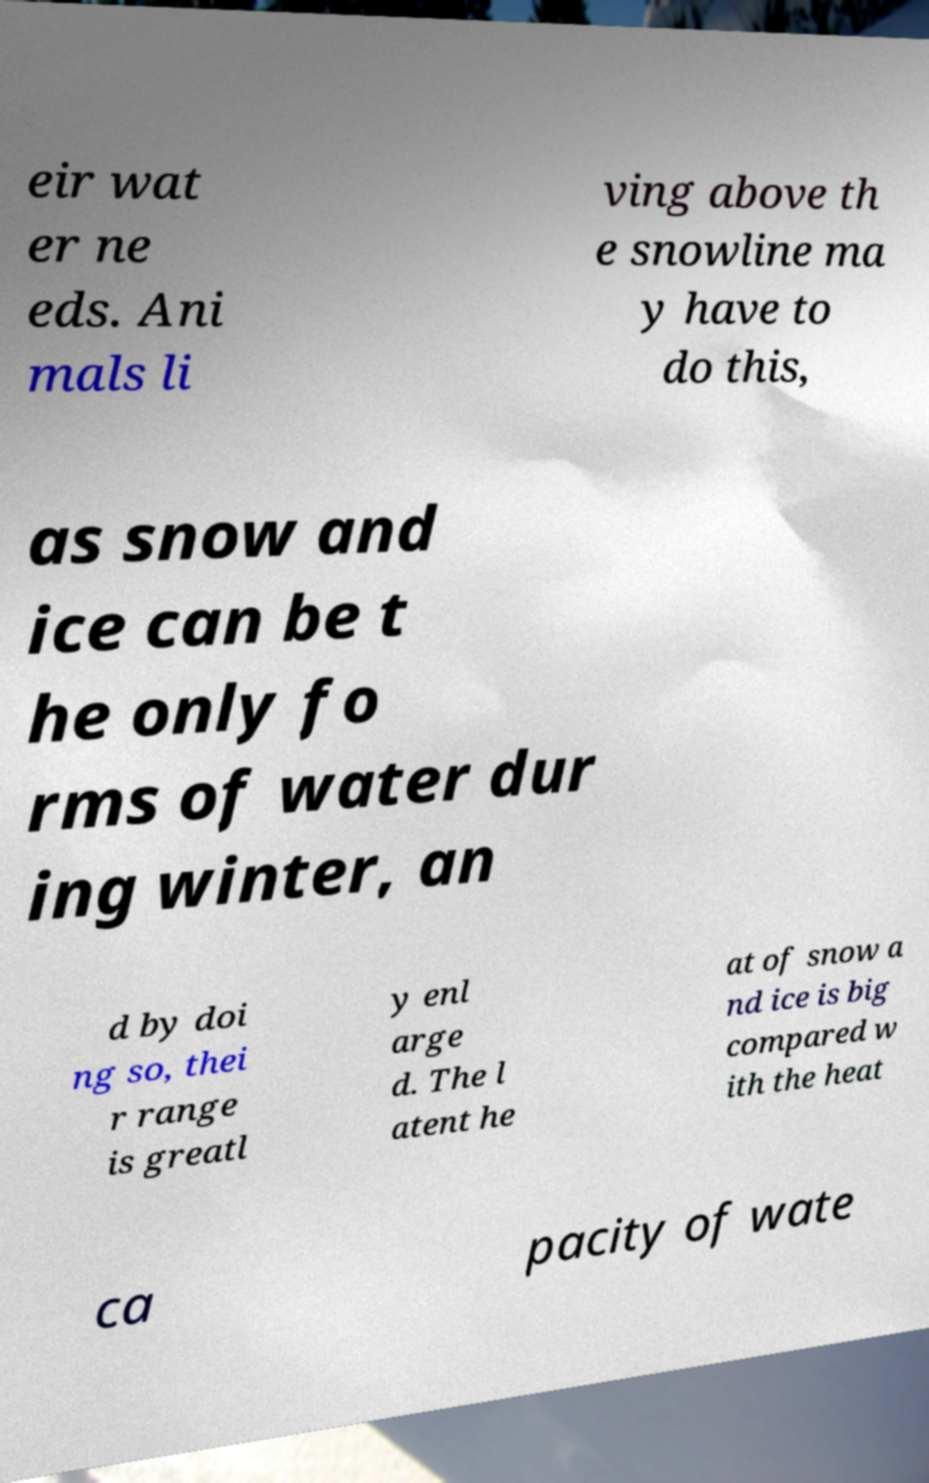For documentation purposes, I need the text within this image transcribed. Could you provide that? eir wat er ne eds. Ani mals li ving above th e snowline ma y have to do this, as snow and ice can be t he only fo rms of water dur ing winter, an d by doi ng so, thei r range is greatl y enl arge d. The l atent he at of snow a nd ice is big compared w ith the heat ca pacity of wate 